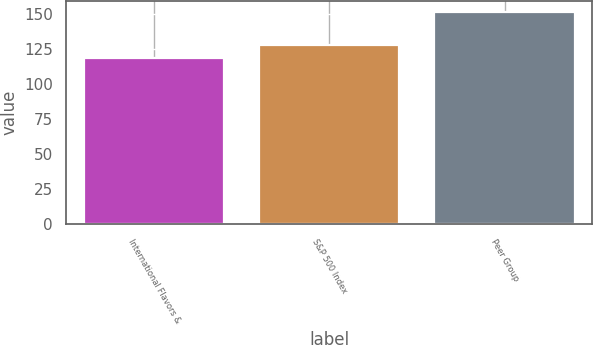Convert chart to OTSL. <chart><loc_0><loc_0><loc_500><loc_500><bar_chart><fcel>International Flavors &<fcel>S&P 500 Index<fcel>Peer Group<nl><fcel>118.97<fcel>128.16<fcel>151.85<nl></chart> 